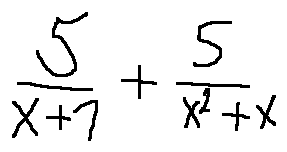<formula> <loc_0><loc_0><loc_500><loc_500>\frac { 5 } { x + 1 } + \frac { 5 } { x ^ { 2 } + x }</formula> 